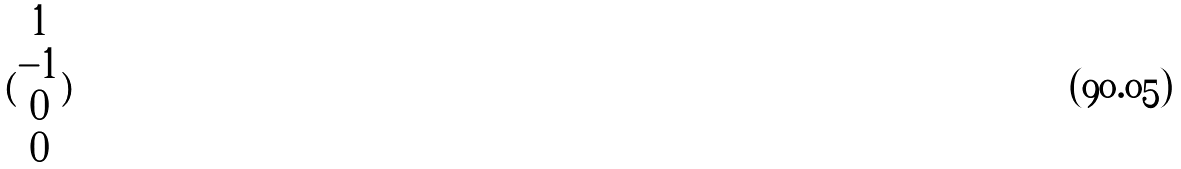<formula> <loc_0><loc_0><loc_500><loc_500>( \begin{matrix} 1 \\ - 1 \\ 0 \\ 0 \end{matrix} )</formula> 